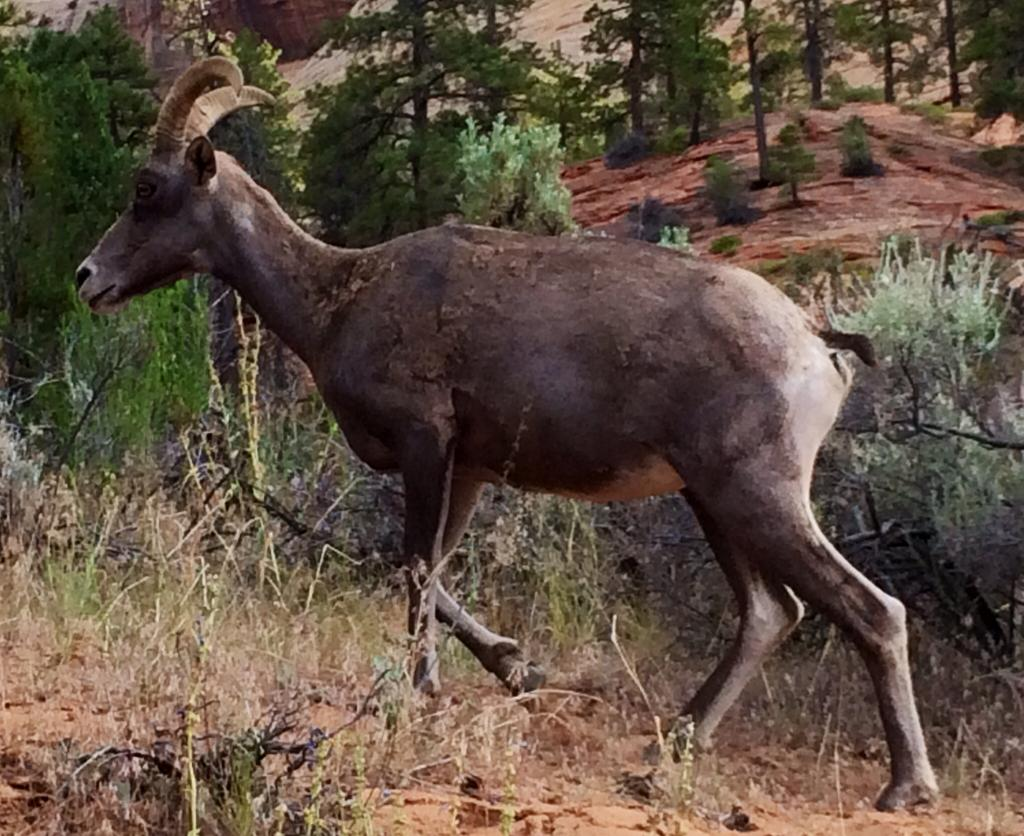What type of artwork is depicted in the image? The image is a painting. What can be seen in the painting? There is an animal in the painting, and it is walking on the ground. What is visible in the background of the painting? There are trees and stone hills in the background of the painting. What type of glue is being used by the animal in the painting? There is no glue present in the painting; it is an animal walking on the ground. How does the animal in the painting respond to a cough? There is no coughing in the painting, as it is a still image of an animal walking on the ground. 